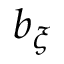Convert formula to latex. <formula><loc_0><loc_0><loc_500><loc_500>b _ { \xi }</formula> 